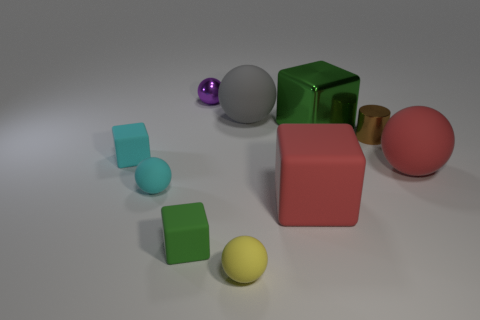Can you tell me what materials the objects seem to be made of? Sure, the objects in the image appear to be made of various materials. The cylinder and two of the blocks have a metallic appearance, likely representing metal. The smaller spheres seem to have a glossy finish, suggesting a plastic or glass-like material. The larger solid-colored blocks and the pink sphere have a matte finish, which could indicate a plastic or rubber material. 